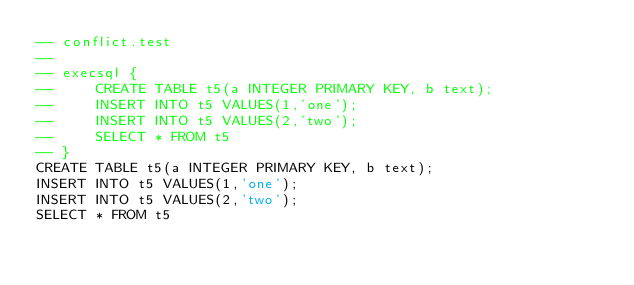Convert code to text. <code><loc_0><loc_0><loc_500><loc_500><_SQL_>-- conflict.test
-- 
-- execsql {
--     CREATE TABLE t5(a INTEGER PRIMARY KEY, b text);
--     INSERT INTO t5 VALUES(1,'one');
--     INSERT INTO t5 VALUES(2,'two');
--     SELECT * FROM t5
-- }
CREATE TABLE t5(a INTEGER PRIMARY KEY, b text);
INSERT INTO t5 VALUES(1,'one');
INSERT INTO t5 VALUES(2,'two');
SELECT * FROM t5</code> 